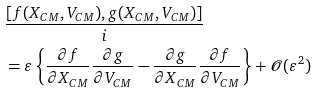<formula> <loc_0><loc_0><loc_500><loc_500>& \frac { [ f ( X _ { C M } , V _ { C M } ) , g ( X _ { C M } , V _ { C M } ) ] } { i } \\ & = \varepsilon \left \{ \frac { \partial f } { \partial X _ { C M } } \frac { \partial g } { \partial V _ { C M } } - \frac { \partial g } { \partial X _ { C M } } \frac { \partial f } { \partial V _ { C M } } \right \} + \mathcal { O } ( \varepsilon ^ { 2 } )</formula> 